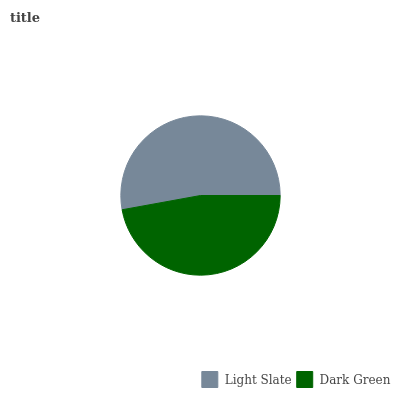Is Dark Green the minimum?
Answer yes or no. Yes. Is Light Slate the maximum?
Answer yes or no. Yes. Is Dark Green the maximum?
Answer yes or no. No. Is Light Slate greater than Dark Green?
Answer yes or no. Yes. Is Dark Green less than Light Slate?
Answer yes or no. Yes. Is Dark Green greater than Light Slate?
Answer yes or no. No. Is Light Slate less than Dark Green?
Answer yes or no. No. Is Light Slate the high median?
Answer yes or no. Yes. Is Dark Green the low median?
Answer yes or no. Yes. Is Dark Green the high median?
Answer yes or no. No. Is Light Slate the low median?
Answer yes or no. No. 